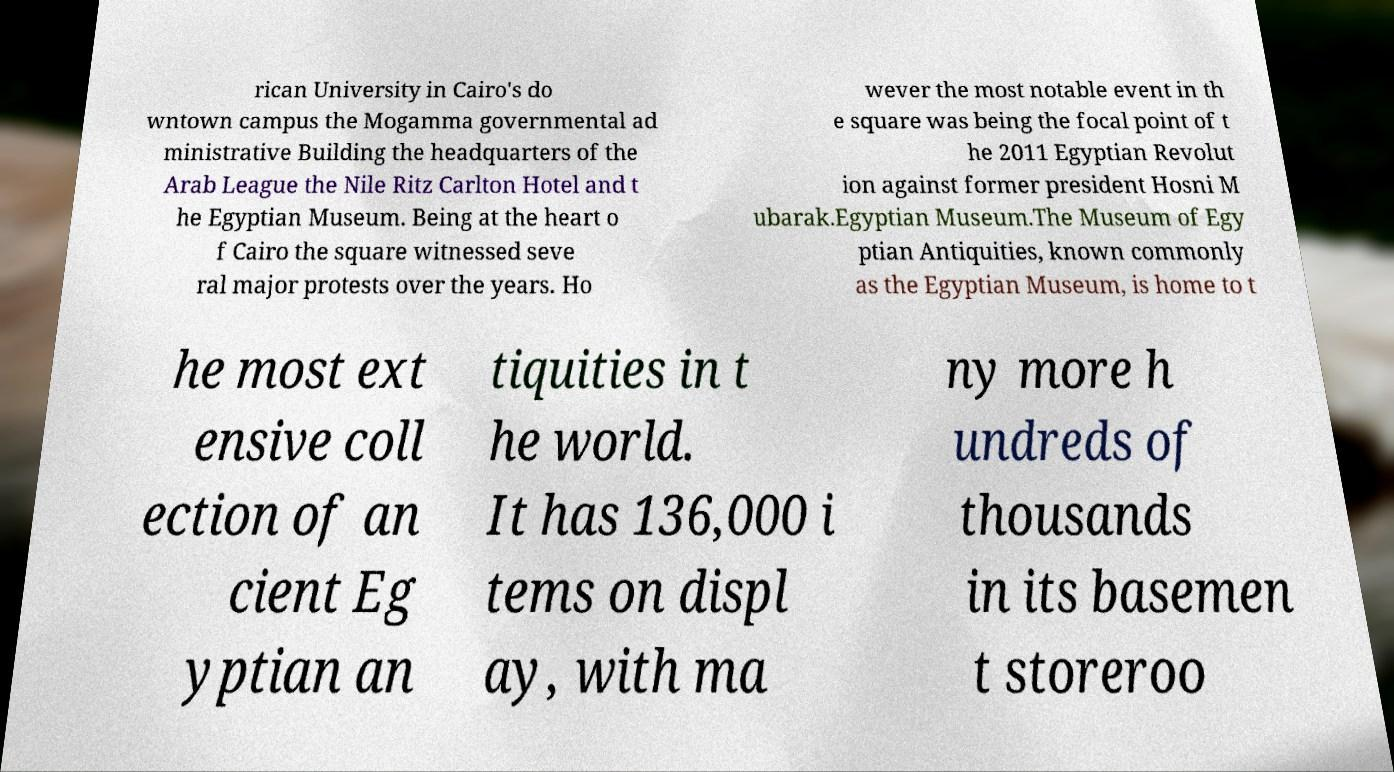Could you assist in decoding the text presented in this image and type it out clearly? rican University in Cairo's do wntown campus the Mogamma governmental ad ministrative Building the headquarters of the Arab League the Nile Ritz Carlton Hotel and t he Egyptian Museum. Being at the heart o f Cairo the square witnessed seve ral major protests over the years. Ho wever the most notable event in th e square was being the focal point of t he 2011 Egyptian Revolut ion against former president Hosni M ubarak.Egyptian Museum.The Museum of Egy ptian Antiquities, known commonly as the Egyptian Museum, is home to t he most ext ensive coll ection of an cient Eg yptian an tiquities in t he world. It has 136,000 i tems on displ ay, with ma ny more h undreds of thousands in its basemen t storeroo 